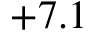Convert formula to latex. <formula><loc_0><loc_0><loc_500><loc_500>+ 7 . 1</formula> 